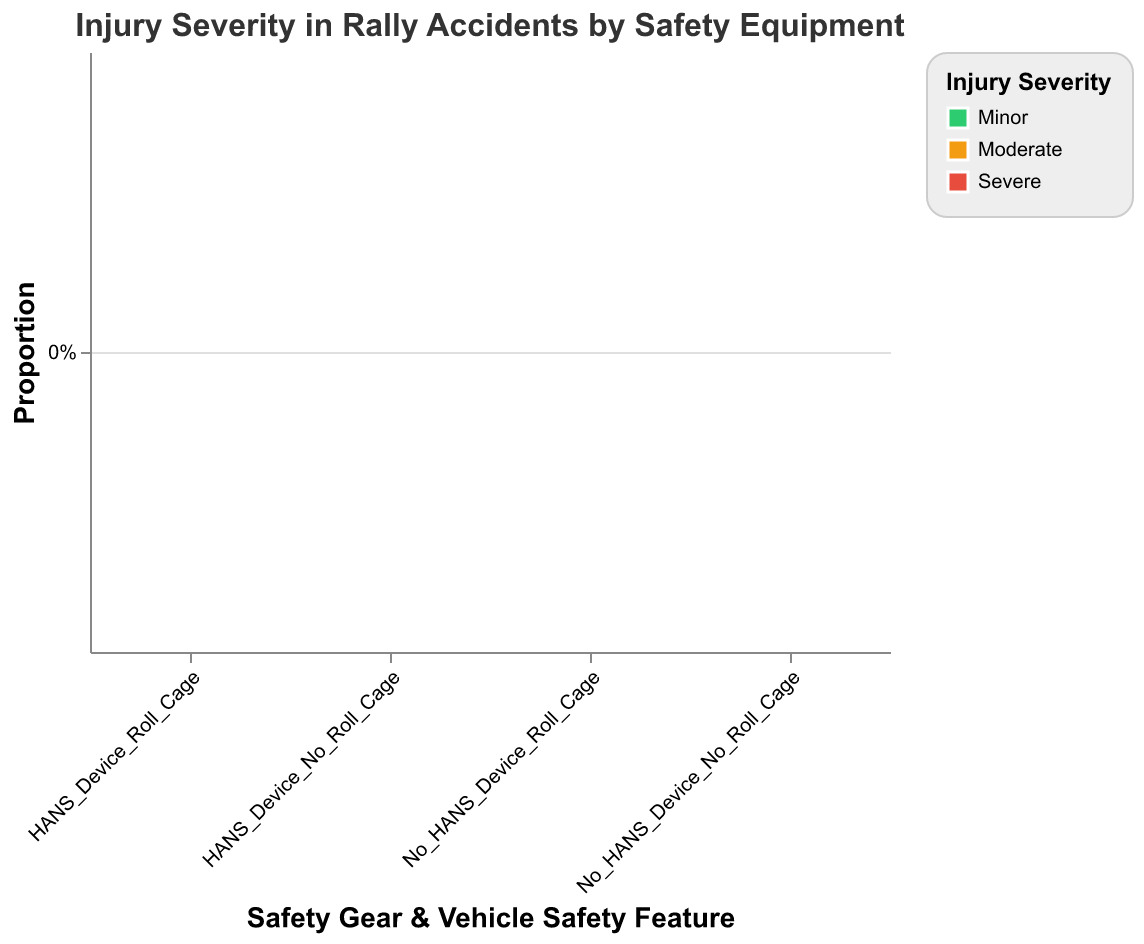What is the title of the figure? The title is typically displayed at the top of the plot, providing a summary of what the plot represents. In this case, it is specified in the code under the "title" attribute. The exact text is "Injury Severity in Rally Accidents by Safety Equipment".
Answer: Injury Severity in Rally Accidents by Safety Equipment What are the two categories on the x-axis? The x-axis shows combinations of Safety Gear and Vehicle Safety Features. These combinations are named after concatenating the values from "Safety_Gear" and "Vehicle_Safety_Feature" columns. The categories are "HANS_Device_Roll_Cage", "HANS_Device_No_Roll_Cage", "No_HANS_Device_Roll_Cage", and "No_HANS_Device_No_Roll_Cage".
Answer: HANS_Device_Roll_Cage, HANS_Device_No_Roll_Cage, No_HANS_Device_Roll_Cage, No_HANS_Device_No_Roll_Cage What injury severity category is represented by the color red? The "color" attribute in the code specifies that red represents "Severe" injuries. This can be seen in the "range" property of the scale used for the color encoding.
Answer: Severe Which safety combination category has the highest proportion of minor injuries? To find the combination with the highest proportion of minor injuries, look for the tallest green section in the plot. From the data and visual properties, "HANS_Device_Roll_Cage" has the highest count of minor injuries (45) compared to the other combinations.
Answer: HANS_Device_Roll_Cage What is the difference in the number of severe injuries between "HANS_Device_Roll_Cage" and "No_HANS_Device_No_Roll_Cage"? First, identify the counts of severe injuries for both combinations. "HANS_Device_Roll_Cage" has 3 severe injuries while "No_HANS_Device_No_Roll_Cage" has 30. The difference is 30 - 3 = 27.
Answer: 27 How does the presence of a roll cage affect the number of severe injuries when the HANS device is not used? Compare the number of severe injuries between the "No_HANS_Device_Roll_Cage" and "No_HANS_Device_No_Roll_Cage" categories. With a roll cage, there are 9 severe injuries. Without a roll cage, there are 30 severe injuries.
Answer: Lower with roll cage Which safety combination has the lowest proportion of moderate injuries? To find this, look for the smallest orange section in the plot for moderate injuries. According to the data, "HANS_Device_Roll_Cage" has the lowest count of moderate injuries (12).
Answer: HANS_Device_Roll_Cage What percentage of injuries in the "HANS_Device_No_Roll_Cage" category are severe? This requires calculating the proportion of severe injuries for the specified category. The counts for "HANS_Device_No_Roll_Cage" are: Minor = 18, Moderate = 22, Severe = 15. Total = 18 + 22 + 15 = 55. So, the percentage of severe injuries is (15 / 55) * 100 ≈ 27.27%.
Answer: 27.27% Is there a safety combination where moderate injuries occur more frequently than minor injuries? Check each safety combination to see if the count of moderate injuries exceeds that of minor injuries. For "No_HANS_Device_No_Roll_Cage", moderate injuries (25) are more frequent than minor injuries (10).
Answer: Yes What is the total count of injuries for each severity level across all safety combinations? Sum the counts for each severity level across all categories. Minor: 45 + 18 + 28 + 10 = 101. Moderate: 12 + 22 + 20 + 25 = 79. Severe: 3 + 15 + 9 + 30 = 57.
Answer: Minor: 101, Moderate: 79, Severe: 57 